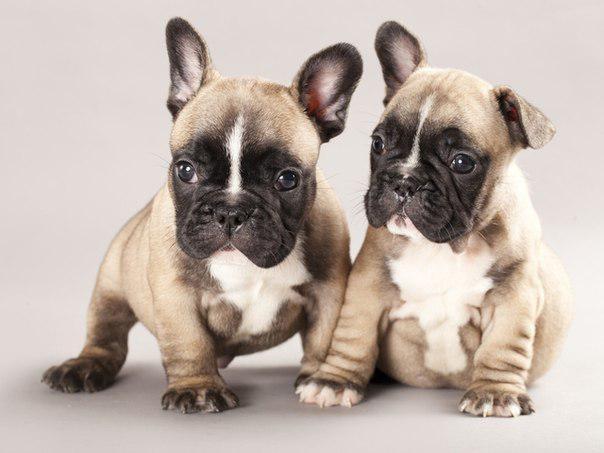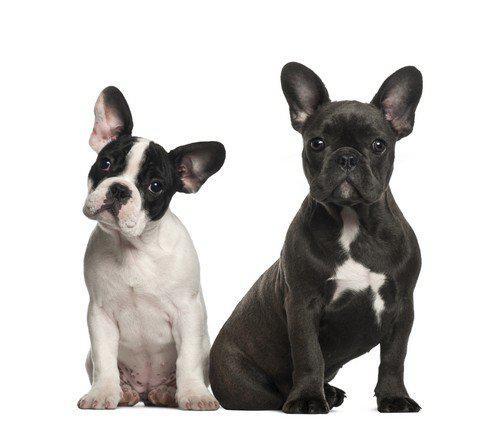The first image is the image on the left, the second image is the image on the right. Examine the images to the left and right. Is the description "The right image contains exactly three dogs." accurate? Answer yes or no. No. The first image is the image on the left, the second image is the image on the right. Analyze the images presented: Is the assertion "Each image contains the same number of dogs, and all dogs are posed side-by-side." valid? Answer yes or no. Yes. 